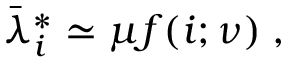<formula> <loc_0><loc_0><loc_500><loc_500>\begin{array} { r } { \bar { \lambda } _ { i } ^ { * } \simeq \mu f ( i ; \nu ) \, , } \end{array}</formula> 